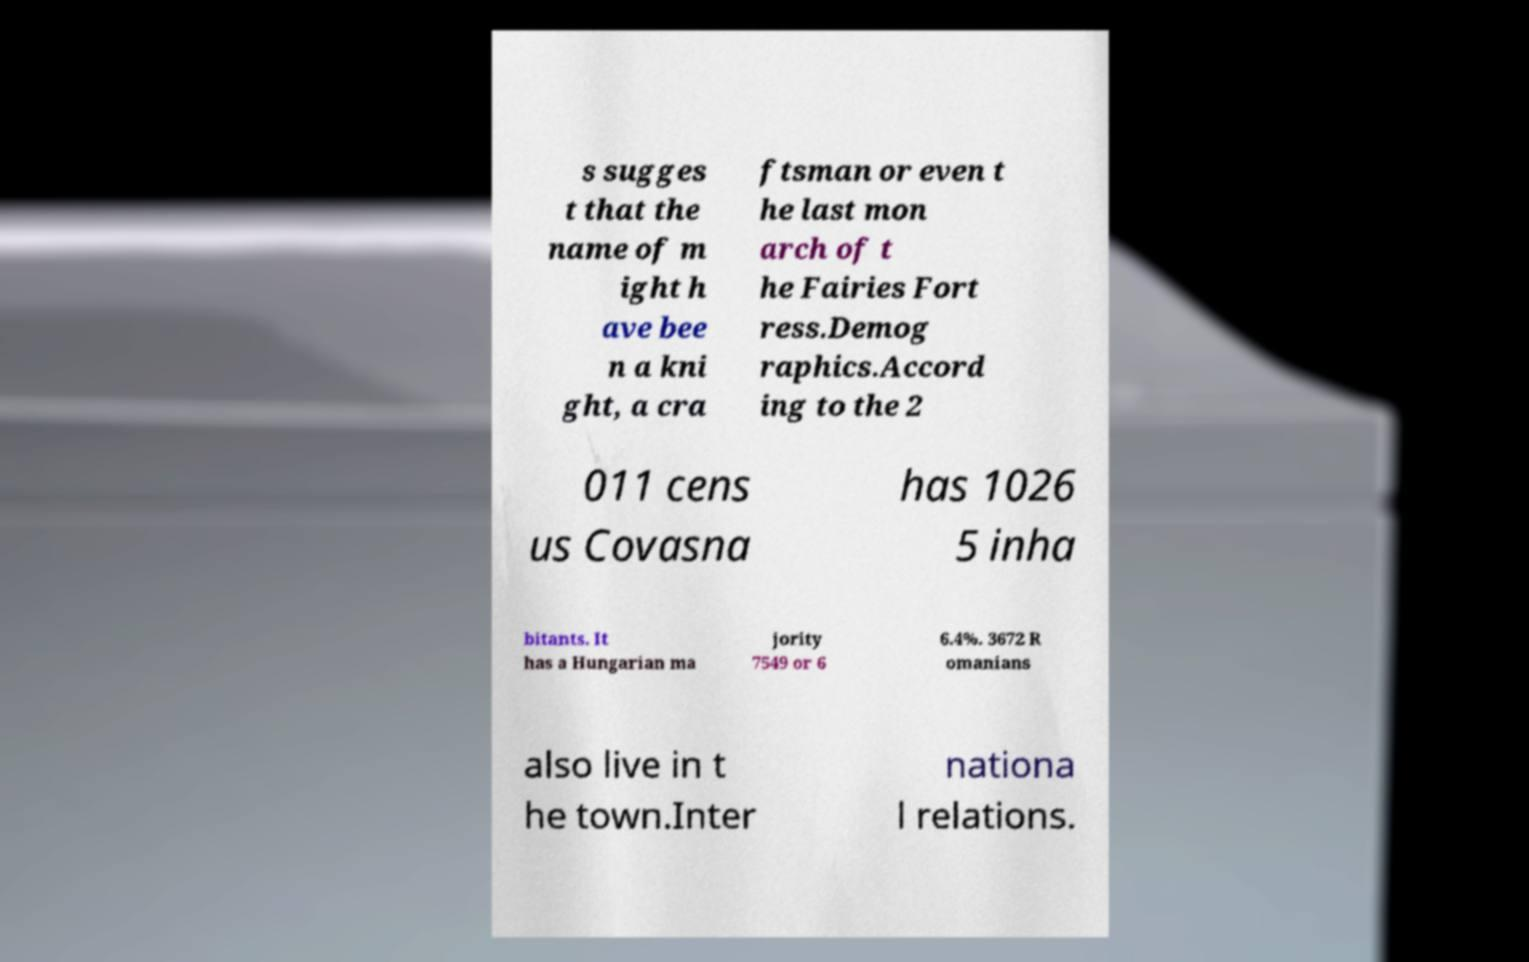Please identify and transcribe the text found in this image. s sugges t that the name of m ight h ave bee n a kni ght, a cra ftsman or even t he last mon arch of t he Fairies Fort ress.Demog raphics.Accord ing to the 2 011 cens us Covasna has 1026 5 inha bitants. It has a Hungarian ma jority 7549 or 6 6.4%. 3672 R omanians also live in t he town.Inter nationa l relations. 